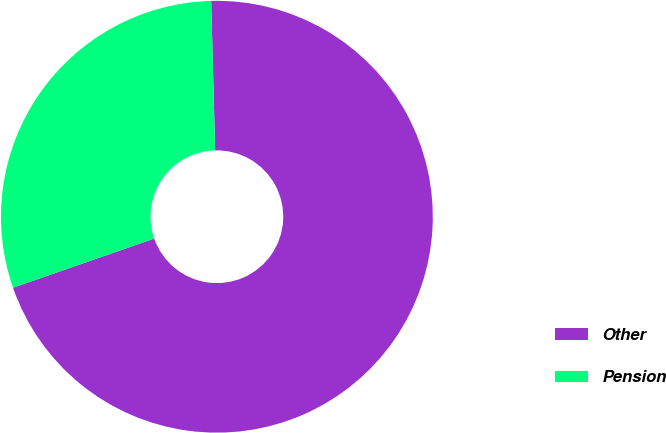Convert chart. <chart><loc_0><loc_0><loc_500><loc_500><pie_chart><fcel>Other<fcel>Pension<nl><fcel>70.09%<fcel>29.91%<nl></chart> 